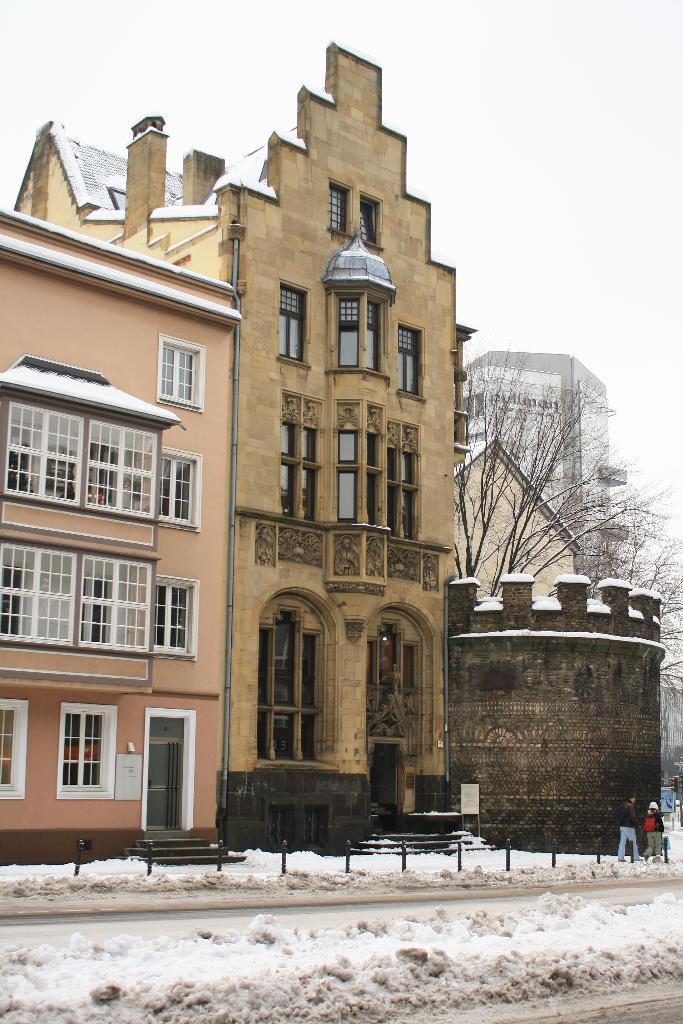How would you summarize this image in a sentence or two? In the image there are buildings in the back with many windows on it, there are two persons walking on the road on right side, there road is covered with snow and above its sky. 